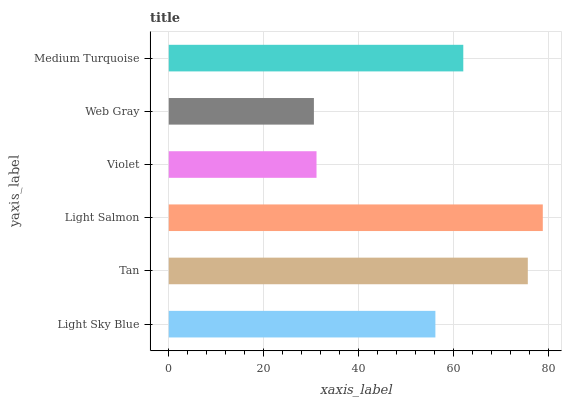Is Web Gray the minimum?
Answer yes or no. Yes. Is Light Salmon the maximum?
Answer yes or no. Yes. Is Tan the minimum?
Answer yes or no. No. Is Tan the maximum?
Answer yes or no. No. Is Tan greater than Light Sky Blue?
Answer yes or no. Yes. Is Light Sky Blue less than Tan?
Answer yes or no. Yes. Is Light Sky Blue greater than Tan?
Answer yes or no. No. Is Tan less than Light Sky Blue?
Answer yes or no. No. Is Medium Turquoise the high median?
Answer yes or no. Yes. Is Light Sky Blue the low median?
Answer yes or no. Yes. Is Tan the high median?
Answer yes or no. No. Is Violet the low median?
Answer yes or no. No. 